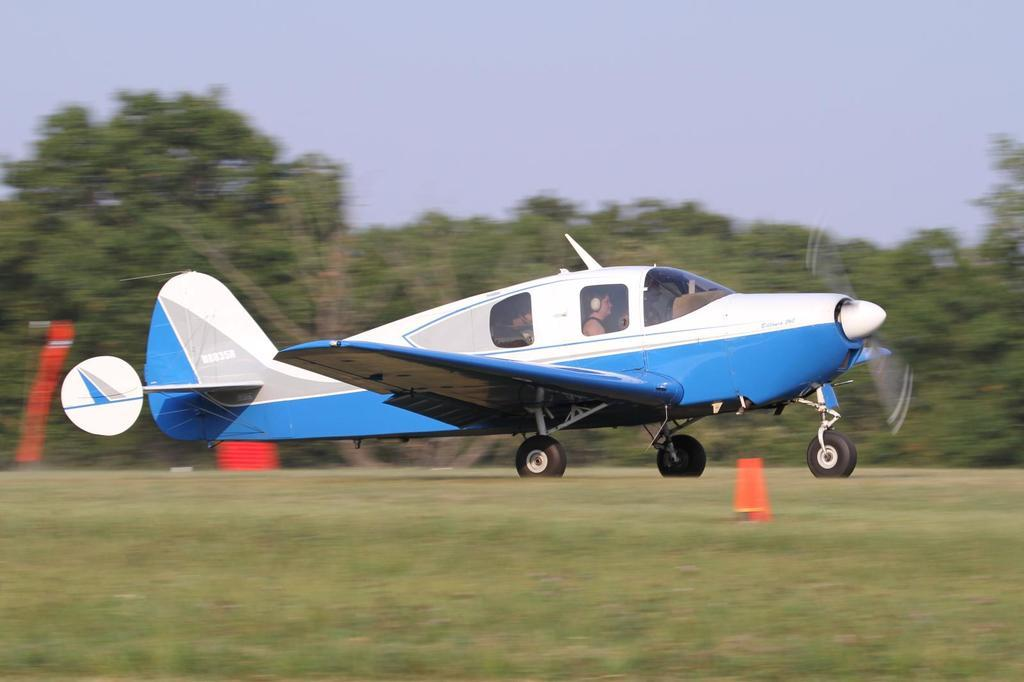What is the main subject of the picture? The main subject of the picture is an aircraft. Where is the aircraft located in the image? The aircraft is on a runway in the center of the picture. Can you tell if there is anyone inside the aircraft? Yes, there is a person inside the aircraft. What can be seen in the background of the image? There are trees in the background of the image. What type of vegetation is in the foreground of the image? There is grass in the foreground of the image. What type of bone can be seen in the image? There is no bone present in the image; it features an aircraft on a runway. Can you tell me how much the soda costs in the image? There is no soda present in the image, so its cost cannot be determined. 